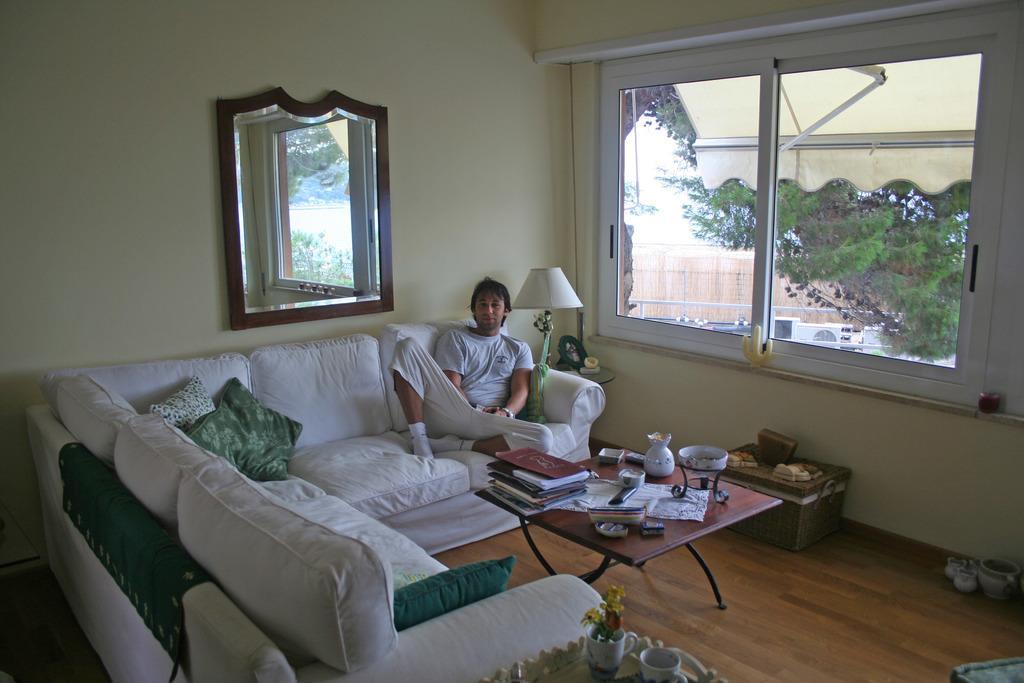How would you summarize this image in a sentence or two? In this picture we can see a room where we have sofa and on sofa there are pillows and person is sitting on that sofa and in front of him there is table and on table we can see books, vase, bowl and beside to him there is a lamp, windows, sun shade, trees and in the background we can see wall and mirror to that wall. 